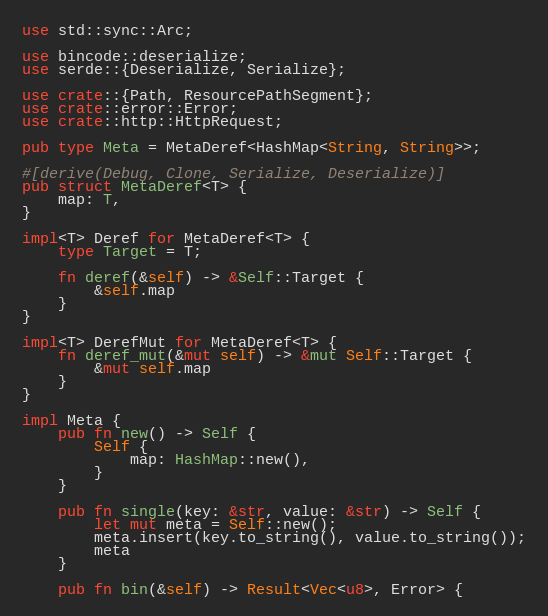Convert code to text. <code><loc_0><loc_0><loc_500><loc_500><_Rust_>use std::sync::Arc;

use bincode::deserialize;
use serde::{Deserialize, Serialize};

use crate::{Path, ResourcePathSegment};
use crate::error::Error;
use crate::http::HttpRequest;

pub type Meta = MetaDeref<HashMap<String, String>>;

#[derive(Debug, Clone, Serialize, Deserialize)]
pub struct MetaDeref<T> {
    map: T,
}

impl<T> Deref for MetaDeref<T> {
    type Target = T;

    fn deref(&self) -> &Self::Target {
        &self.map
    }
}

impl<T> DerefMut for MetaDeref<T> {
    fn deref_mut(&mut self) -> &mut Self::Target {
        &mut self.map
    }
}

impl Meta {
    pub fn new() -> Self {
        Self {
            map: HashMap::new(),
        }
    }

    pub fn single(key: &str, value: &str) -> Self {
        let mut meta = Self::new();
        meta.insert(key.to_string(), value.to_string());
        meta
    }

    pub fn bin(&self) -> Result<Vec<u8>, Error> {</code> 